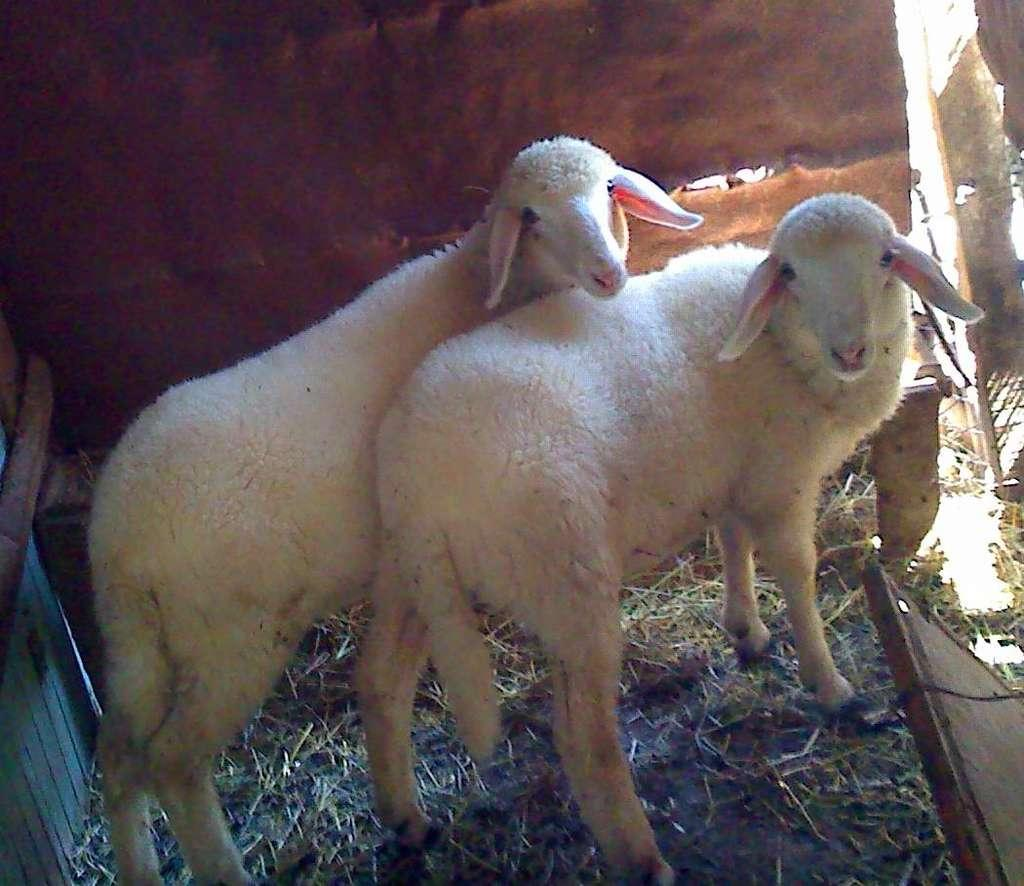How many animals are present in the image? There are two sheep in the image. What type of vegetation is on the ground in the image? There is grass on the ground in the image. What color is the object on the left side of the image? The object on the left side of the image is blue. What can be seen on the right side of the image? There are unspecified objects or elements on the right side of the image. What type of flowers are being protested in the image? There is no protest or flowers present in the image; it features two sheep, grass, and a blue object. 